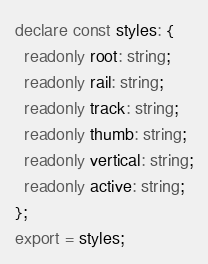<code> <loc_0><loc_0><loc_500><loc_500><_TypeScript_>declare const styles: {
  readonly root: string;
  readonly rail: string;
  readonly track: string;
  readonly thumb: string;
  readonly vertical: string;
  readonly active: string;
};
export = styles;
</code> 